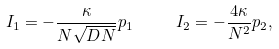<formula> <loc_0><loc_0><loc_500><loc_500>I _ { 1 } = - \frac { \kappa } { N \sqrt { D N } } p _ { 1 } \, \quad \ I _ { 2 } = - \frac { 4 \kappa } { N ^ { 2 } } p _ { 2 } ,</formula> 